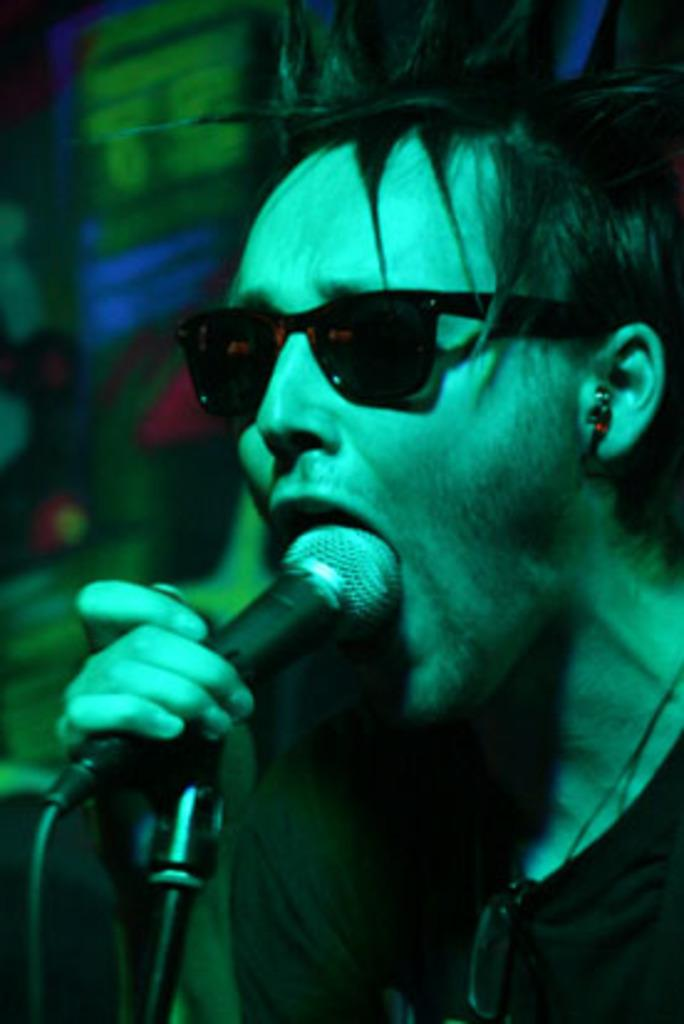What is the main subject in the foreground of the picture? There is a person in the foreground of the picture. What can be observed about the person's appearance? The person is wearing sunglasses. What is the person holding in the image? The person is holding a microphone. What can be seen in the background of the image? There are many other objects in the background of the image. How many cakes are being served at the person's home in the image? There is no information about cakes or a home in the image, so we cannot determine how many cakes are being served. What is the person's account balance in the image? There is no information about an account or balance in the image, so we cannot determine the person's account balance. 